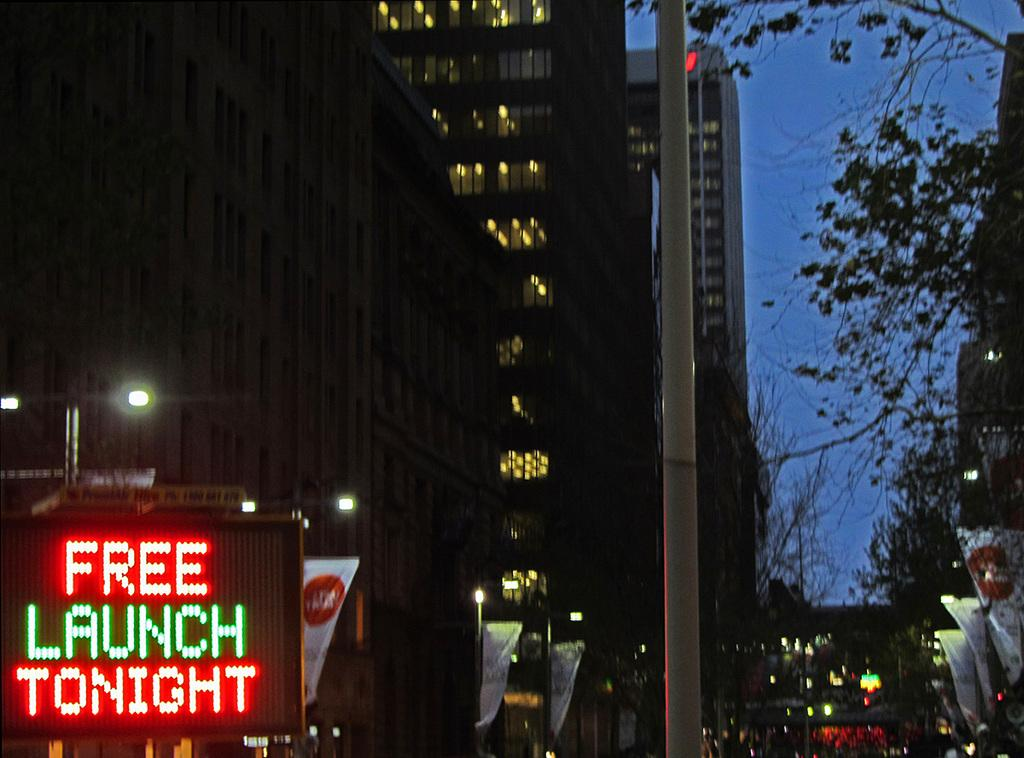What type of structures can be seen in the image? There are buildings in the image. What type of lighting is present in the image? Street lights are present in the image. What type of decorations are visible in the image? Banners are visible in the image. What type of vegetation is present in the image? Trees are present in the image. What type of vertical structures are visible in the image? Poles are visible in the image. What type of electronic device is present in the image? A digital screen is present in the image. What part of the natural environment is visible in the image? The sky is visible in the background on the right side of the image. Can you see a cat twisting around a pipe in the image? There is no cat or pipe present in the image. 